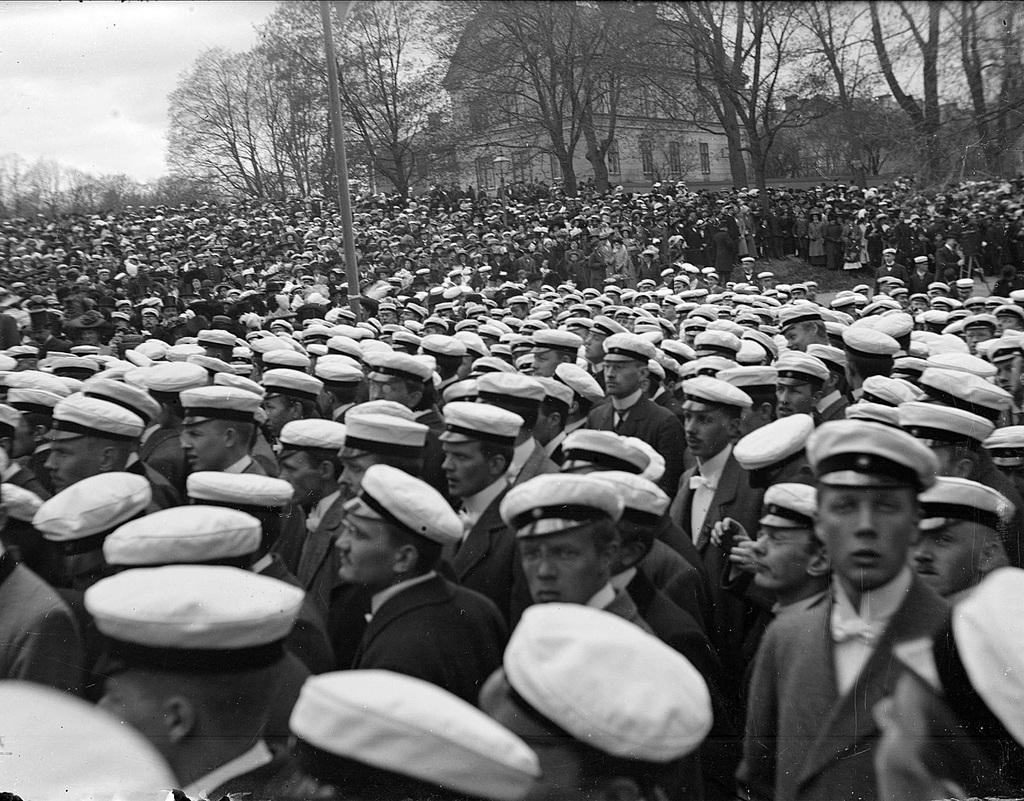In one or two sentences, can you explain what this image depicts? This is a black and white image. In this image there are many people wearing caps. Also there is a pole. In the background there are trees and building with windows. And there is sky. 